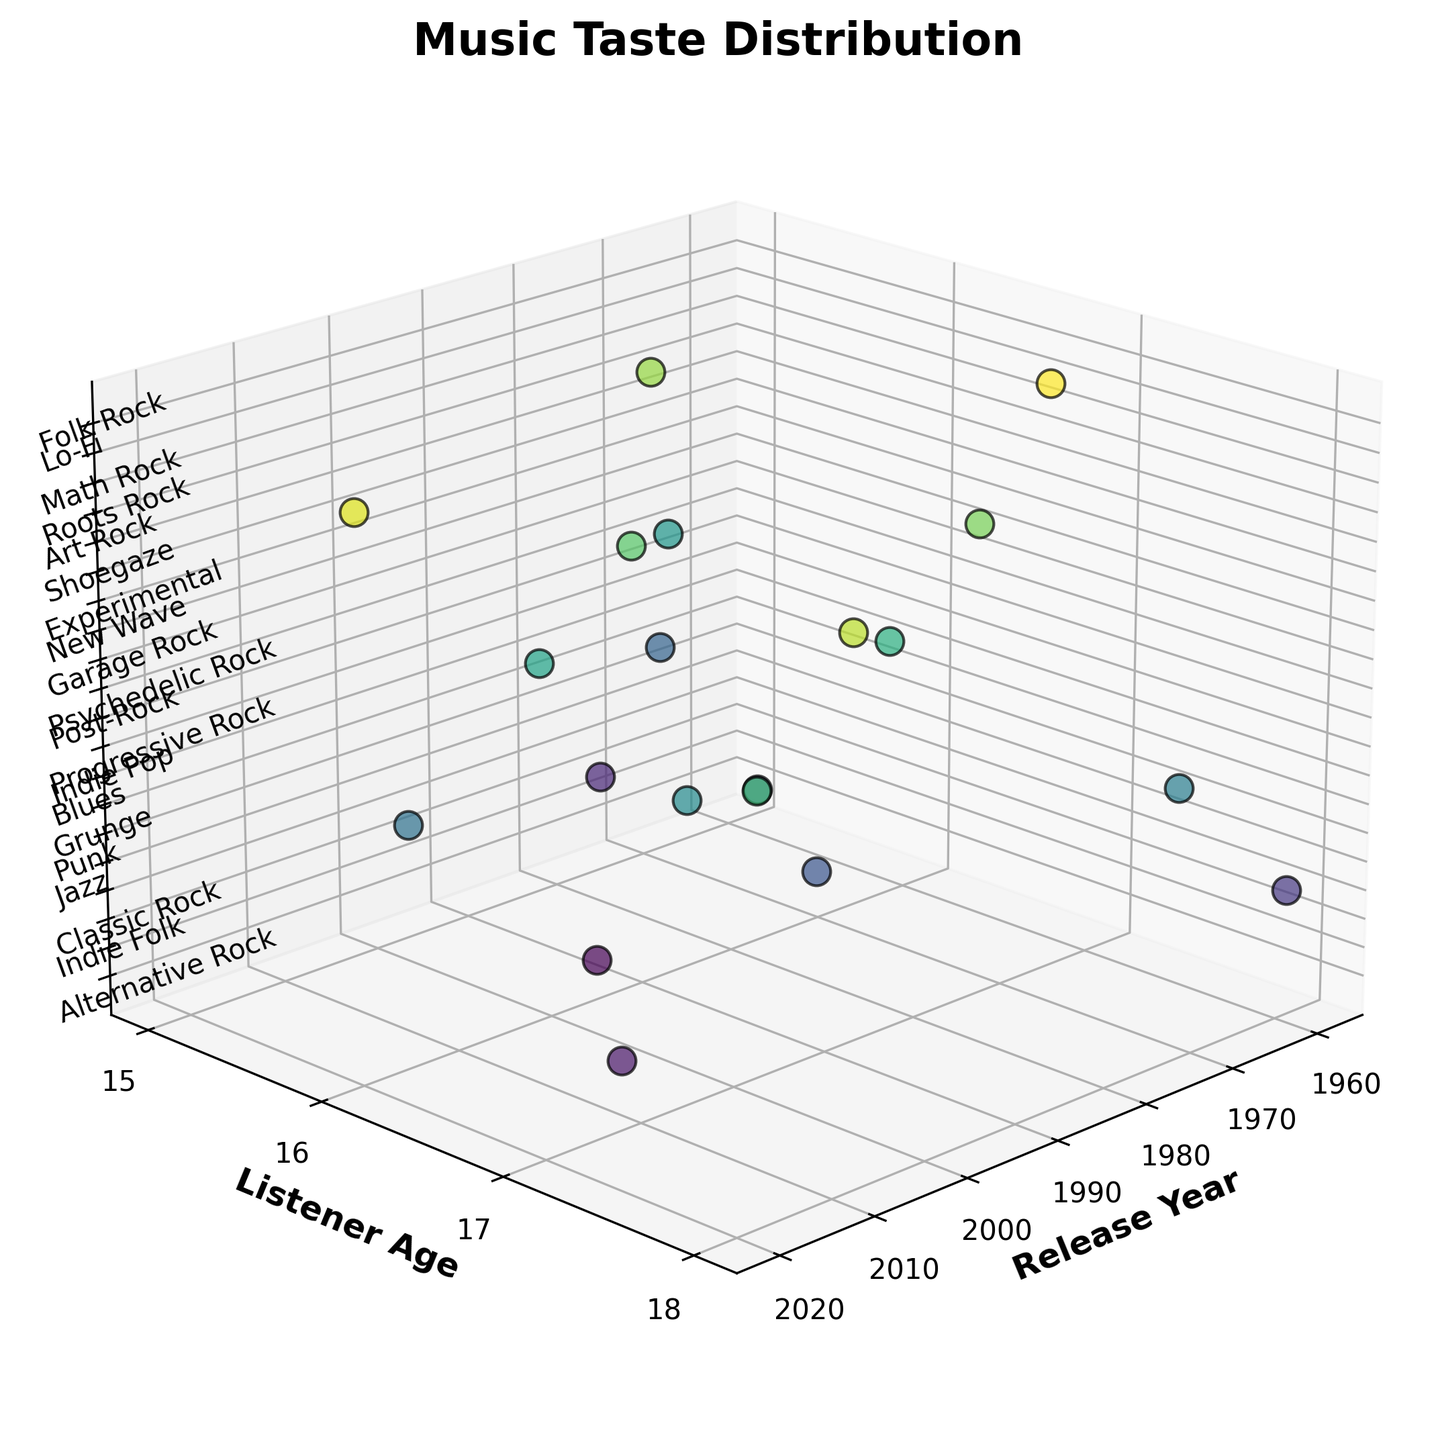What is the title of the figure? The title of the figure is generally displayed at the top. In this figure, the title is "Music Taste Distribution".
Answer: Music Taste Distribution How is the axis labeled for showing the age of listeners? The y-axis displays the age of listeners and is labeled as "Listener Age".
Answer: Listener Age What genre has the oldest release year among those represented? The genre "Jazz" is associated with the oldest release year, which is 1959. This information is visible by noting the lowest point on the x-axis corresponding to the "Jazz" data label.
Answer: Jazz Which genre does a 16-year-old listener from 1968 prefer? Check the y-axis for the listener's age (16 years old) and the x-axis for the release year (1968). The genre corresponding to this data point is "Blues".
Answer: Blues What is the range of listener ages in the figure? The y-axis represents the listener's age. By observing the minimum and maximum points on this axis, we see that the range is from 15 to 18 years old.
Answer: 15 to 18 How many genres are represented in the plot? Each unique label on the z-axis represents a different genre. Counting these labels provides the number of genres. There are 20 genres listed.
Answer: 20 Are there any genres with data points scattered across multiple listener ages? Look for genres with more than one data point on the y-axis. Examples include "Alternative Rock," "Grunge," and several others.
Answer: Yes What genre has the most recent release year? By identifying the highest year on the x-axis, we note that "Lo-Fi" has the most recent release year, which is 2020.
Answer: Lo-Fi Which genres appear between the years 1980 and 1990? Find the genres with release years in the 1980 to 1990 range on the x-axis. "New Wave" (1983) falls within this range.
Answer: New Wave Is there any genre that a 17-year-old likes which was released in the 2010s? Look for data points where the y-axis reads 17 years old and the x-axis falls within the 2010s. "Indie Folk" (2012) and "Indie Pop" (2015) match this criteria.
Answer: Indie Folk, Indie Pop 